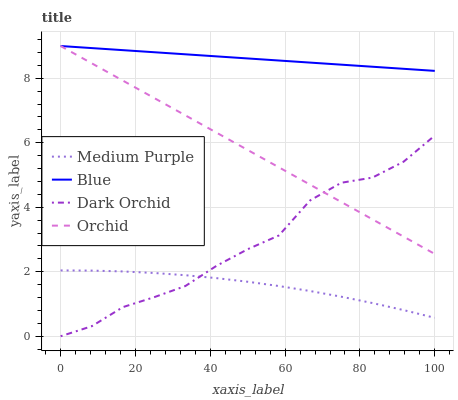Does Medium Purple have the minimum area under the curve?
Answer yes or no. Yes. Does Blue have the maximum area under the curve?
Answer yes or no. Yes. Does Dark Orchid have the minimum area under the curve?
Answer yes or no. No. Does Dark Orchid have the maximum area under the curve?
Answer yes or no. No. Is Orchid the smoothest?
Answer yes or no. Yes. Is Dark Orchid the roughest?
Answer yes or no. Yes. Is Blue the smoothest?
Answer yes or no. No. Is Blue the roughest?
Answer yes or no. No. Does Dark Orchid have the lowest value?
Answer yes or no. Yes. Does Blue have the lowest value?
Answer yes or no. No. Does Orchid have the highest value?
Answer yes or no. Yes. Does Dark Orchid have the highest value?
Answer yes or no. No. Is Medium Purple less than Orchid?
Answer yes or no. Yes. Is Blue greater than Medium Purple?
Answer yes or no. Yes. Does Dark Orchid intersect Orchid?
Answer yes or no. Yes. Is Dark Orchid less than Orchid?
Answer yes or no. No. Is Dark Orchid greater than Orchid?
Answer yes or no. No. Does Medium Purple intersect Orchid?
Answer yes or no. No. 